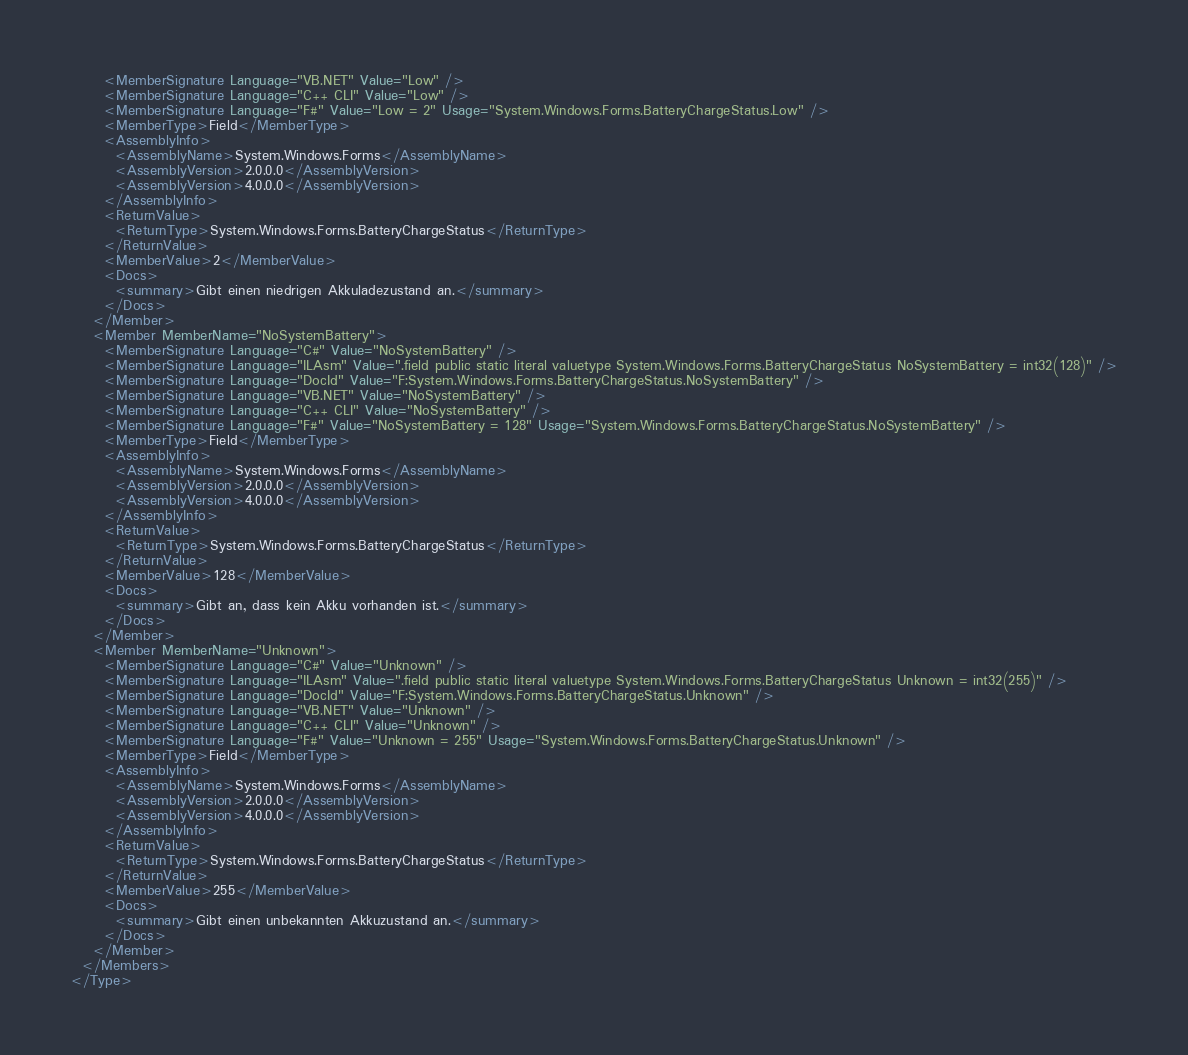Convert code to text. <code><loc_0><loc_0><loc_500><loc_500><_XML_>      <MemberSignature Language="VB.NET" Value="Low" />
      <MemberSignature Language="C++ CLI" Value="Low" />
      <MemberSignature Language="F#" Value="Low = 2" Usage="System.Windows.Forms.BatteryChargeStatus.Low" />
      <MemberType>Field</MemberType>
      <AssemblyInfo>
        <AssemblyName>System.Windows.Forms</AssemblyName>
        <AssemblyVersion>2.0.0.0</AssemblyVersion>
        <AssemblyVersion>4.0.0.0</AssemblyVersion>
      </AssemblyInfo>
      <ReturnValue>
        <ReturnType>System.Windows.Forms.BatteryChargeStatus</ReturnType>
      </ReturnValue>
      <MemberValue>2</MemberValue>
      <Docs>
        <summary>Gibt einen niedrigen Akkuladezustand an.</summary>
      </Docs>
    </Member>
    <Member MemberName="NoSystemBattery">
      <MemberSignature Language="C#" Value="NoSystemBattery" />
      <MemberSignature Language="ILAsm" Value=".field public static literal valuetype System.Windows.Forms.BatteryChargeStatus NoSystemBattery = int32(128)" />
      <MemberSignature Language="DocId" Value="F:System.Windows.Forms.BatteryChargeStatus.NoSystemBattery" />
      <MemberSignature Language="VB.NET" Value="NoSystemBattery" />
      <MemberSignature Language="C++ CLI" Value="NoSystemBattery" />
      <MemberSignature Language="F#" Value="NoSystemBattery = 128" Usage="System.Windows.Forms.BatteryChargeStatus.NoSystemBattery" />
      <MemberType>Field</MemberType>
      <AssemblyInfo>
        <AssemblyName>System.Windows.Forms</AssemblyName>
        <AssemblyVersion>2.0.0.0</AssemblyVersion>
        <AssemblyVersion>4.0.0.0</AssemblyVersion>
      </AssemblyInfo>
      <ReturnValue>
        <ReturnType>System.Windows.Forms.BatteryChargeStatus</ReturnType>
      </ReturnValue>
      <MemberValue>128</MemberValue>
      <Docs>
        <summary>Gibt an, dass kein Akku vorhanden ist.</summary>
      </Docs>
    </Member>
    <Member MemberName="Unknown">
      <MemberSignature Language="C#" Value="Unknown" />
      <MemberSignature Language="ILAsm" Value=".field public static literal valuetype System.Windows.Forms.BatteryChargeStatus Unknown = int32(255)" />
      <MemberSignature Language="DocId" Value="F:System.Windows.Forms.BatteryChargeStatus.Unknown" />
      <MemberSignature Language="VB.NET" Value="Unknown" />
      <MemberSignature Language="C++ CLI" Value="Unknown" />
      <MemberSignature Language="F#" Value="Unknown = 255" Usage="System.Windows.Forms.BatteryChargeStatus.Unknown" />
      <MemberType>Field</MemberType>
      <AssemblyInfo>
        <AssemblyName>System.Windows.Forms</AssemblyName>
        <AssemblyVersion>2.0.0.0</AssemblyVersion>
        <AssemblyVersion>4.0.0.0</AssemblyVersion>
      </AssemblyInfo>
      <ReturnValue>
        <ReturnType>System.Windows.Forms.BatteryChargeStatus</ReturnType>
      </ReturnValue>
      <MemberValue>255</MemberValue>
      <Docs>
        <summary>Gibt einen unbekannten Akkuzustand an.</summary>
      </Docs>
    </Member>
  </Members>
</Type></code> 